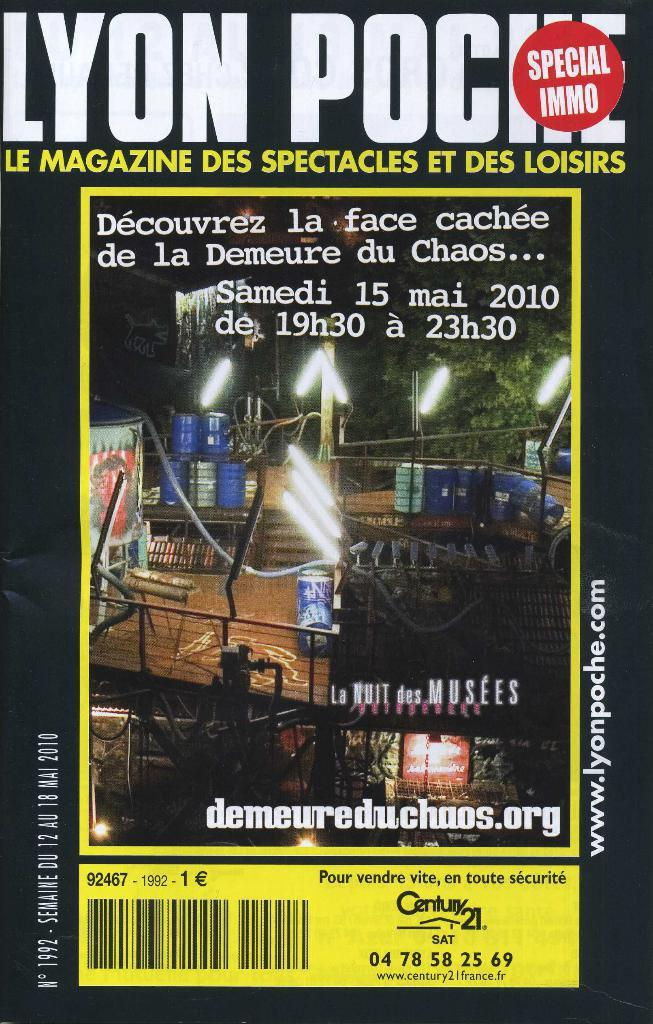<image>
Summarize the visual content of the image. a magazine with special immo at the top of it 